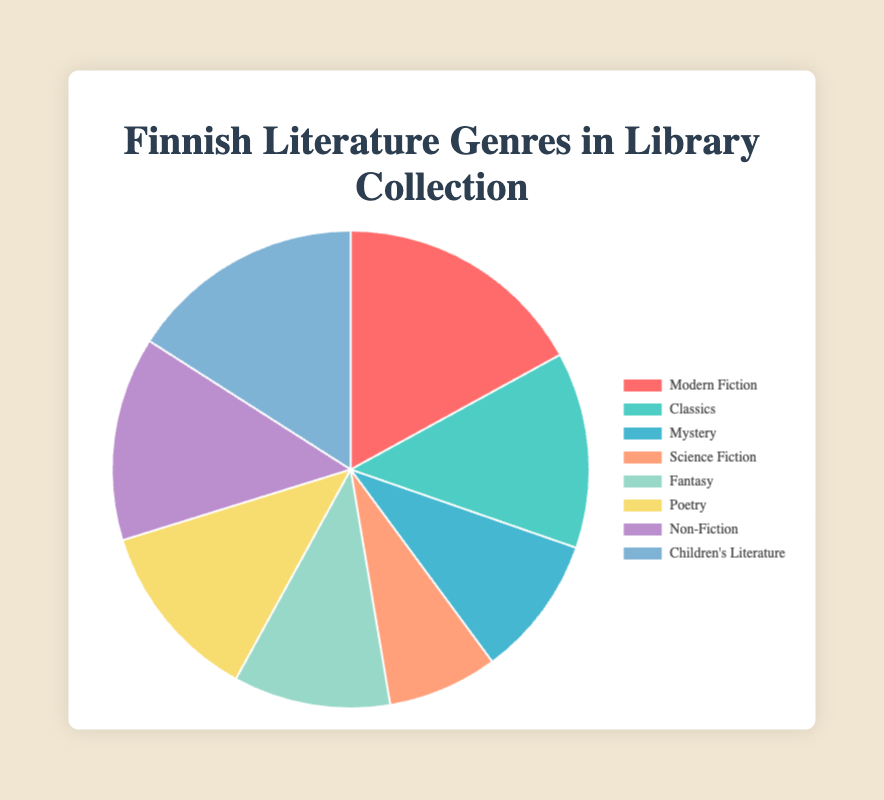What genre has the highest book count? The pie chart shows the book counts of various genres. By inspecting the data, we see that "Modern Fiction" has the highest value at 320 books.
Answer: Modern Fiction How many more books are there in Modern Fiction than in Science Fiction? The book count for Modern Fiction is 320 and for Science Fiction is 140. Subtracting these values gives 320 - 140.
Answer: 180 What is the sum of the books in Classics and Poetry genres? The book count for Classics is 250 and for Poetry is 230. Summing these values gives 250 + 230.
Answer: 480 Which genre has fewer books, Mystery or Science Fiction? By comparing the book counts, Mystery has 180 books, and Science Fiction has 140 books.
Answer: Science Fiction What is the total number of books in the collection? Adding the book counts for all genres: 320 (Modern Fiction) + 250 (Classics) + 180 (Mystery) + 140 (Science Fiction) + 200 (Fantasy) + 230 (Poetry) + 260 (Non-Fiction) + 300 (Children’s Literature) = 1880.
Answer: 1880 Which genres have book counts between 200 and 300? Looking at the data, the genres with book counts in this range are Fantasy (200), Poetry (230), Non-Fiction (260), and Children’s Literature (300).
Answer: Fantasy, Poetry, Non-Fiction, Children’s Literature How does the book count of Children's Literature compare to Non-Fiction? Children's Literature has 300 books and Non-Fiction has 260 books.
Answer: Children's Literature has more books What is the average book count per genre? Divide the total book count (1880) by the number of genres (8). The average is 1880 / 8.
Answer: 235 Which genre is represented by the green color in the pie chart? The green color corresponds to Non-Fiction, which has a book count of 260.
Answer: Non-Fiction How many genres have more than 250 books? By inspecting the data, the genres with more than 250 books are Modern Fiction (320) and Children’s Literature (300).
Answer: 2 